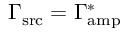Convert formula to latex. <formula><loc_0><loc_0><loc_500><loc_500>\Gamma _ { s r c } = \Gamma _ { a m p } ^ { \ast }</formula> 